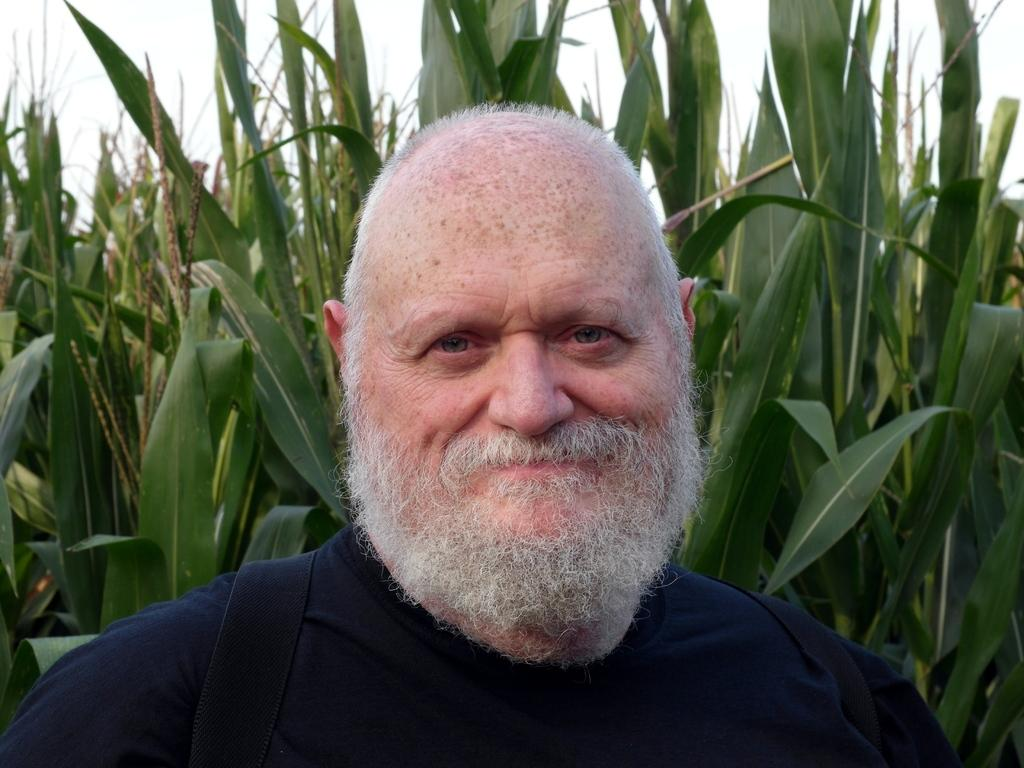Who is present in the image? There is a man in the image. What is the man's facial expression? The man is smiling. What type of vegetation can be seen in the image? There are plants in the image. What can be seen in the background of the image? The sky is visible in the background of the image. What type of lock is used to secure the man's comfort in the image? There is no lock or reference to comfort in the image; it simply features a man smiling with plants and a visible sky in the background. 